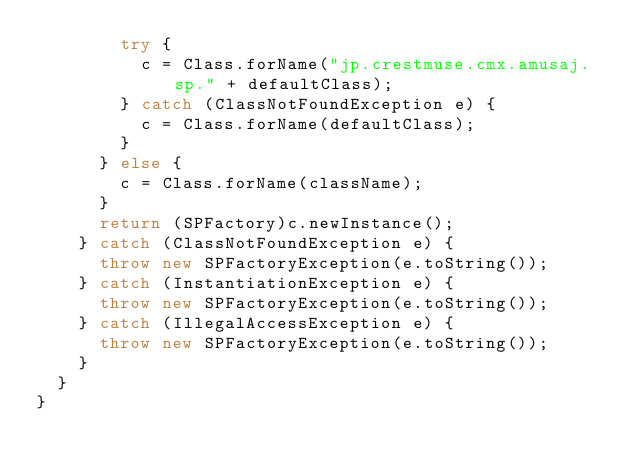Convert code to text. <code><loc_0><loc_0><loc_500><loc_500><_Java_>        try {
          c = Class.forName("jp.crestmuse.cmx.amusaj.sp." + defaultClass);
        } catch (ClassNotFoundException e) {
          c = Class.forName(defaultClass);
        }
      } else {
        c = Class.forName(className);
      }
      return (SPFactory)c.newInstance();
    } catch (ClassNotFoundException e) {
      throw new SPFactoryException(e.toString());
    } catch (InstantiationException e) {
      throw new SPFactoryException(e.toString());
    } catch (IllegalAccessException e) {
      throw new SPFactoryException(e.toString());
    }
  }
}
</code> 